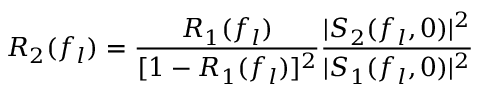<formula> <loc_0><loc_0><loc_500><loc_500>R _ { 2 } ( f _ { l } ) = \frac { R _ { 1 } ( f _ { l } ) } { [ 1 - R _ { 1 } ( f _ { l } ) ] ^ { 2 } } \frac { | S _ { 2 } ( f _ { l } , 0 ) | ^ { 2 } } { | S _ { 1 } ( f _ { l } , 0 ) | ^ { 2 } }</formula> 